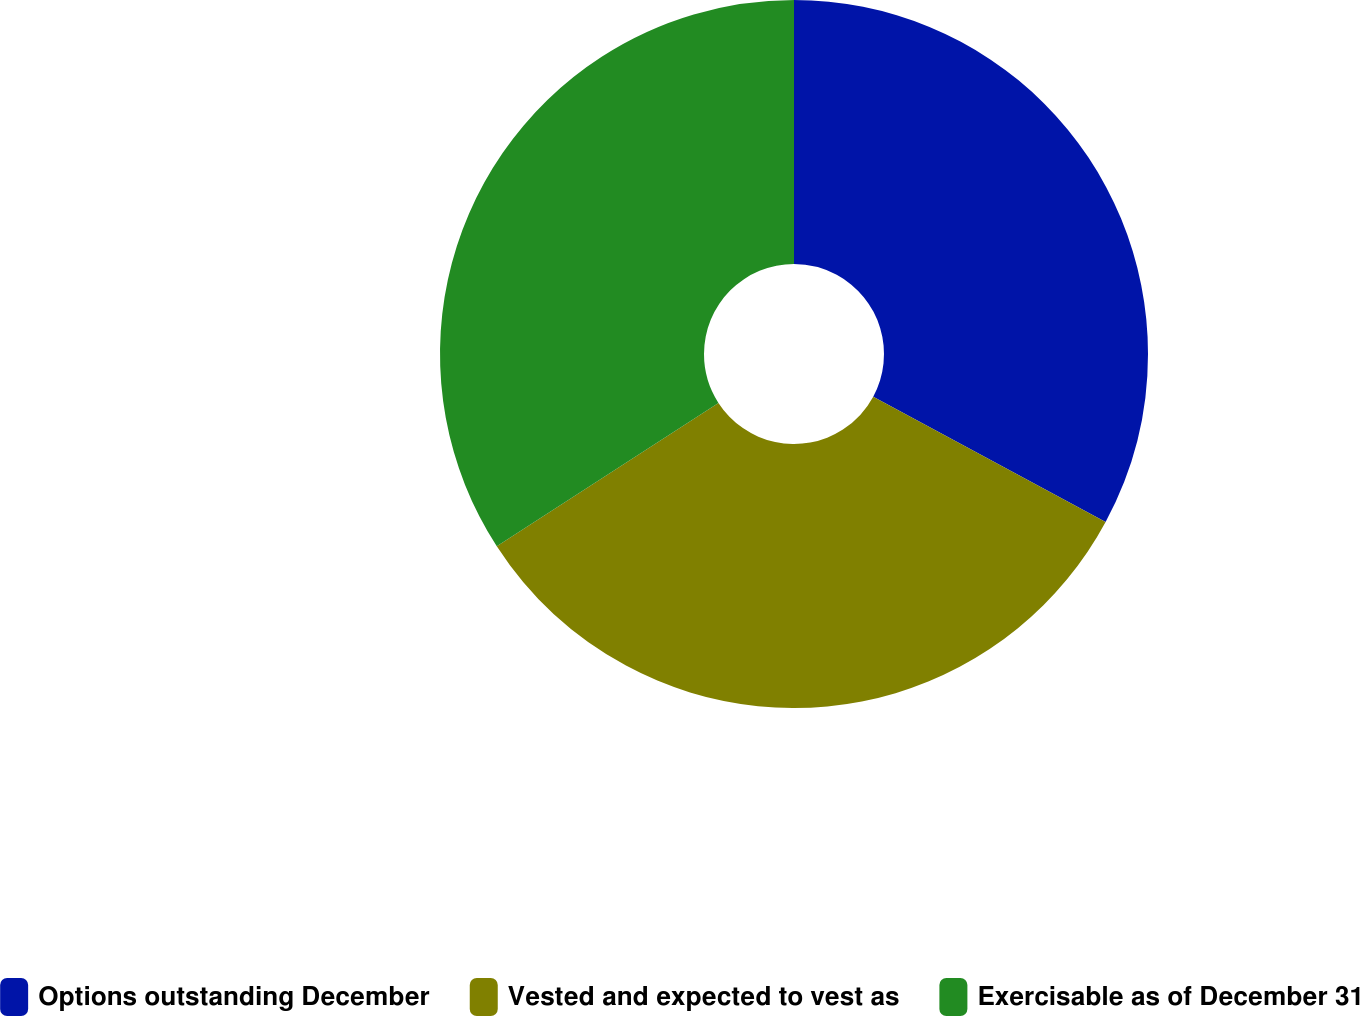Convert chart. <chart><loc_0><loc_0><loc_500><loc_500><pie_chart><fcel>Options outstanding December<fcel>Vested and expected to vest as<fcel>Exercisable as of December 31<nl><fcel>32.87%<fcel>32.99%<fcel>34.14%<nl></chart> 